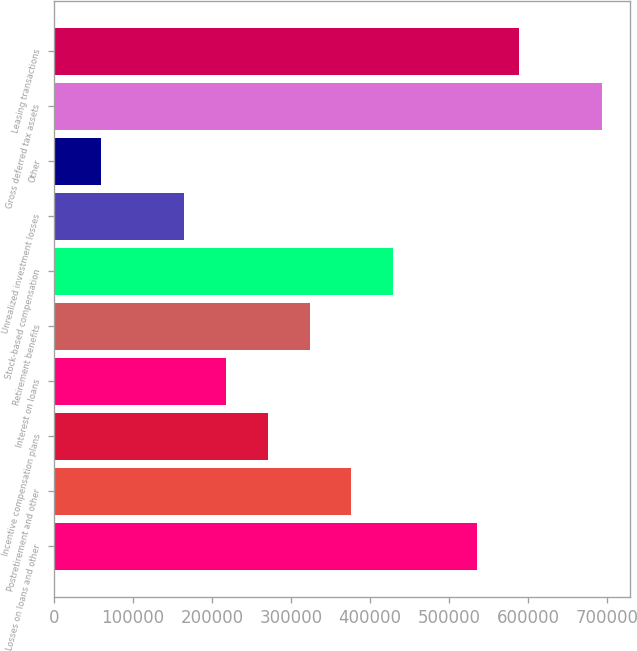<chart> <loc_0><loc_0><loc_500><loc_500><bar_chart><fcel>Losses on loans and other<fcel>Postretirement and other<fcel>Incentive compensation plans<fcel>Interest on loans<fcel>Retirement benefits<fcel>Stock-based compensation<fcel>Unrealized investment losses<fcel>Other<fcel>Gross deferred tax assets<fcel>Leasing transactions<nl><fcel>534897<fcel>376237<fcel>270464<fcel>217577<fcel>323351<fcel>429124<fcel>164691<fcel>58917.6<fcel>693557<fcel>587784<nl></chart> 